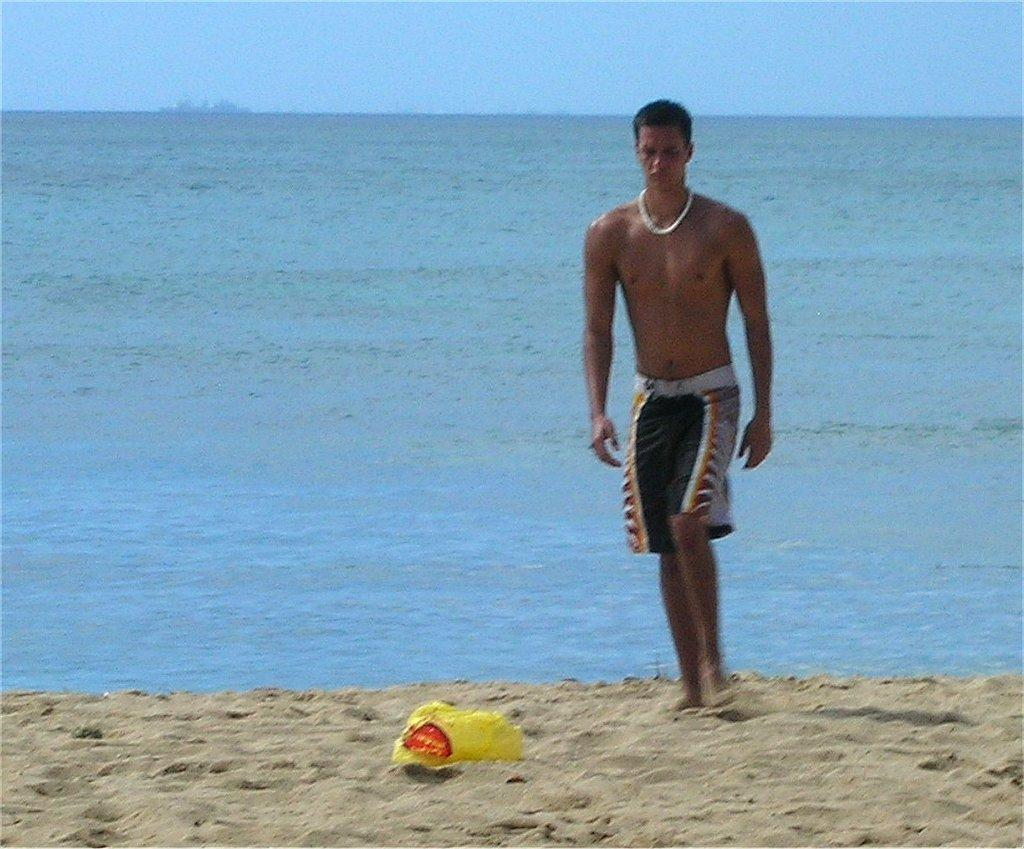What is the man in the image doing? The man is standing near the sea shore. What object can be seen on the sand? There is a basket on the sand. How would you describe the sky in the image? The sky is clear in the image. What type of debt is the man discussing with the sea in the image? There is no indication in the image that the man is discussing any debt, nor is there any interaction between the man and the sea. 